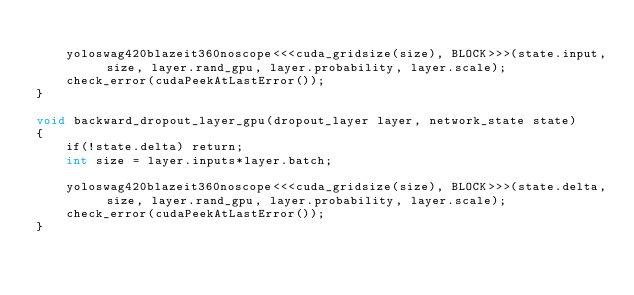Convert code to text. <code><loc_0><loc_0><loc_500><loc_500><_Cuda_>
    yoloswag420blazeit360noscope<<<cuda_gridsize(size), BLOCK>>>(state.input, size, layer.rand_gpu, layer.probability, layer.scale);
    check_error(cudaPeekAtLastError());
}

void backward_dropout_layer_gpu(dropout_layer layer, network_state state)
{
    if(!state.delta) return;
    int size = layer.inputs*layer.batch;

    yoloswag420blazeit360noscope<<<cuda_gridsize(size), BLOCK>>>(state.delta, size, layer.rand_gpu, layer.probability, layer.scale);
    check_error(cudaPeekAtLastError());
}
</code> 